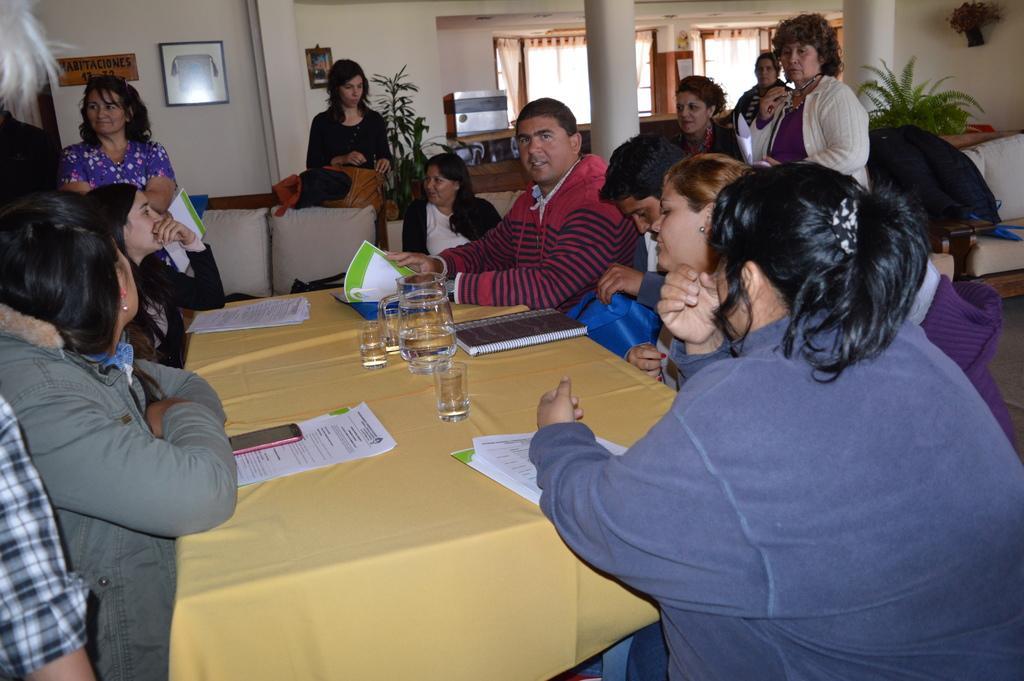How would you summarize this image in a sentence or two? In this image I can see the group sitting and some people are standing. In front of these people there is a table. On the table there is a book,paper,glass and flask. There is a frame and board attached to the wall. 